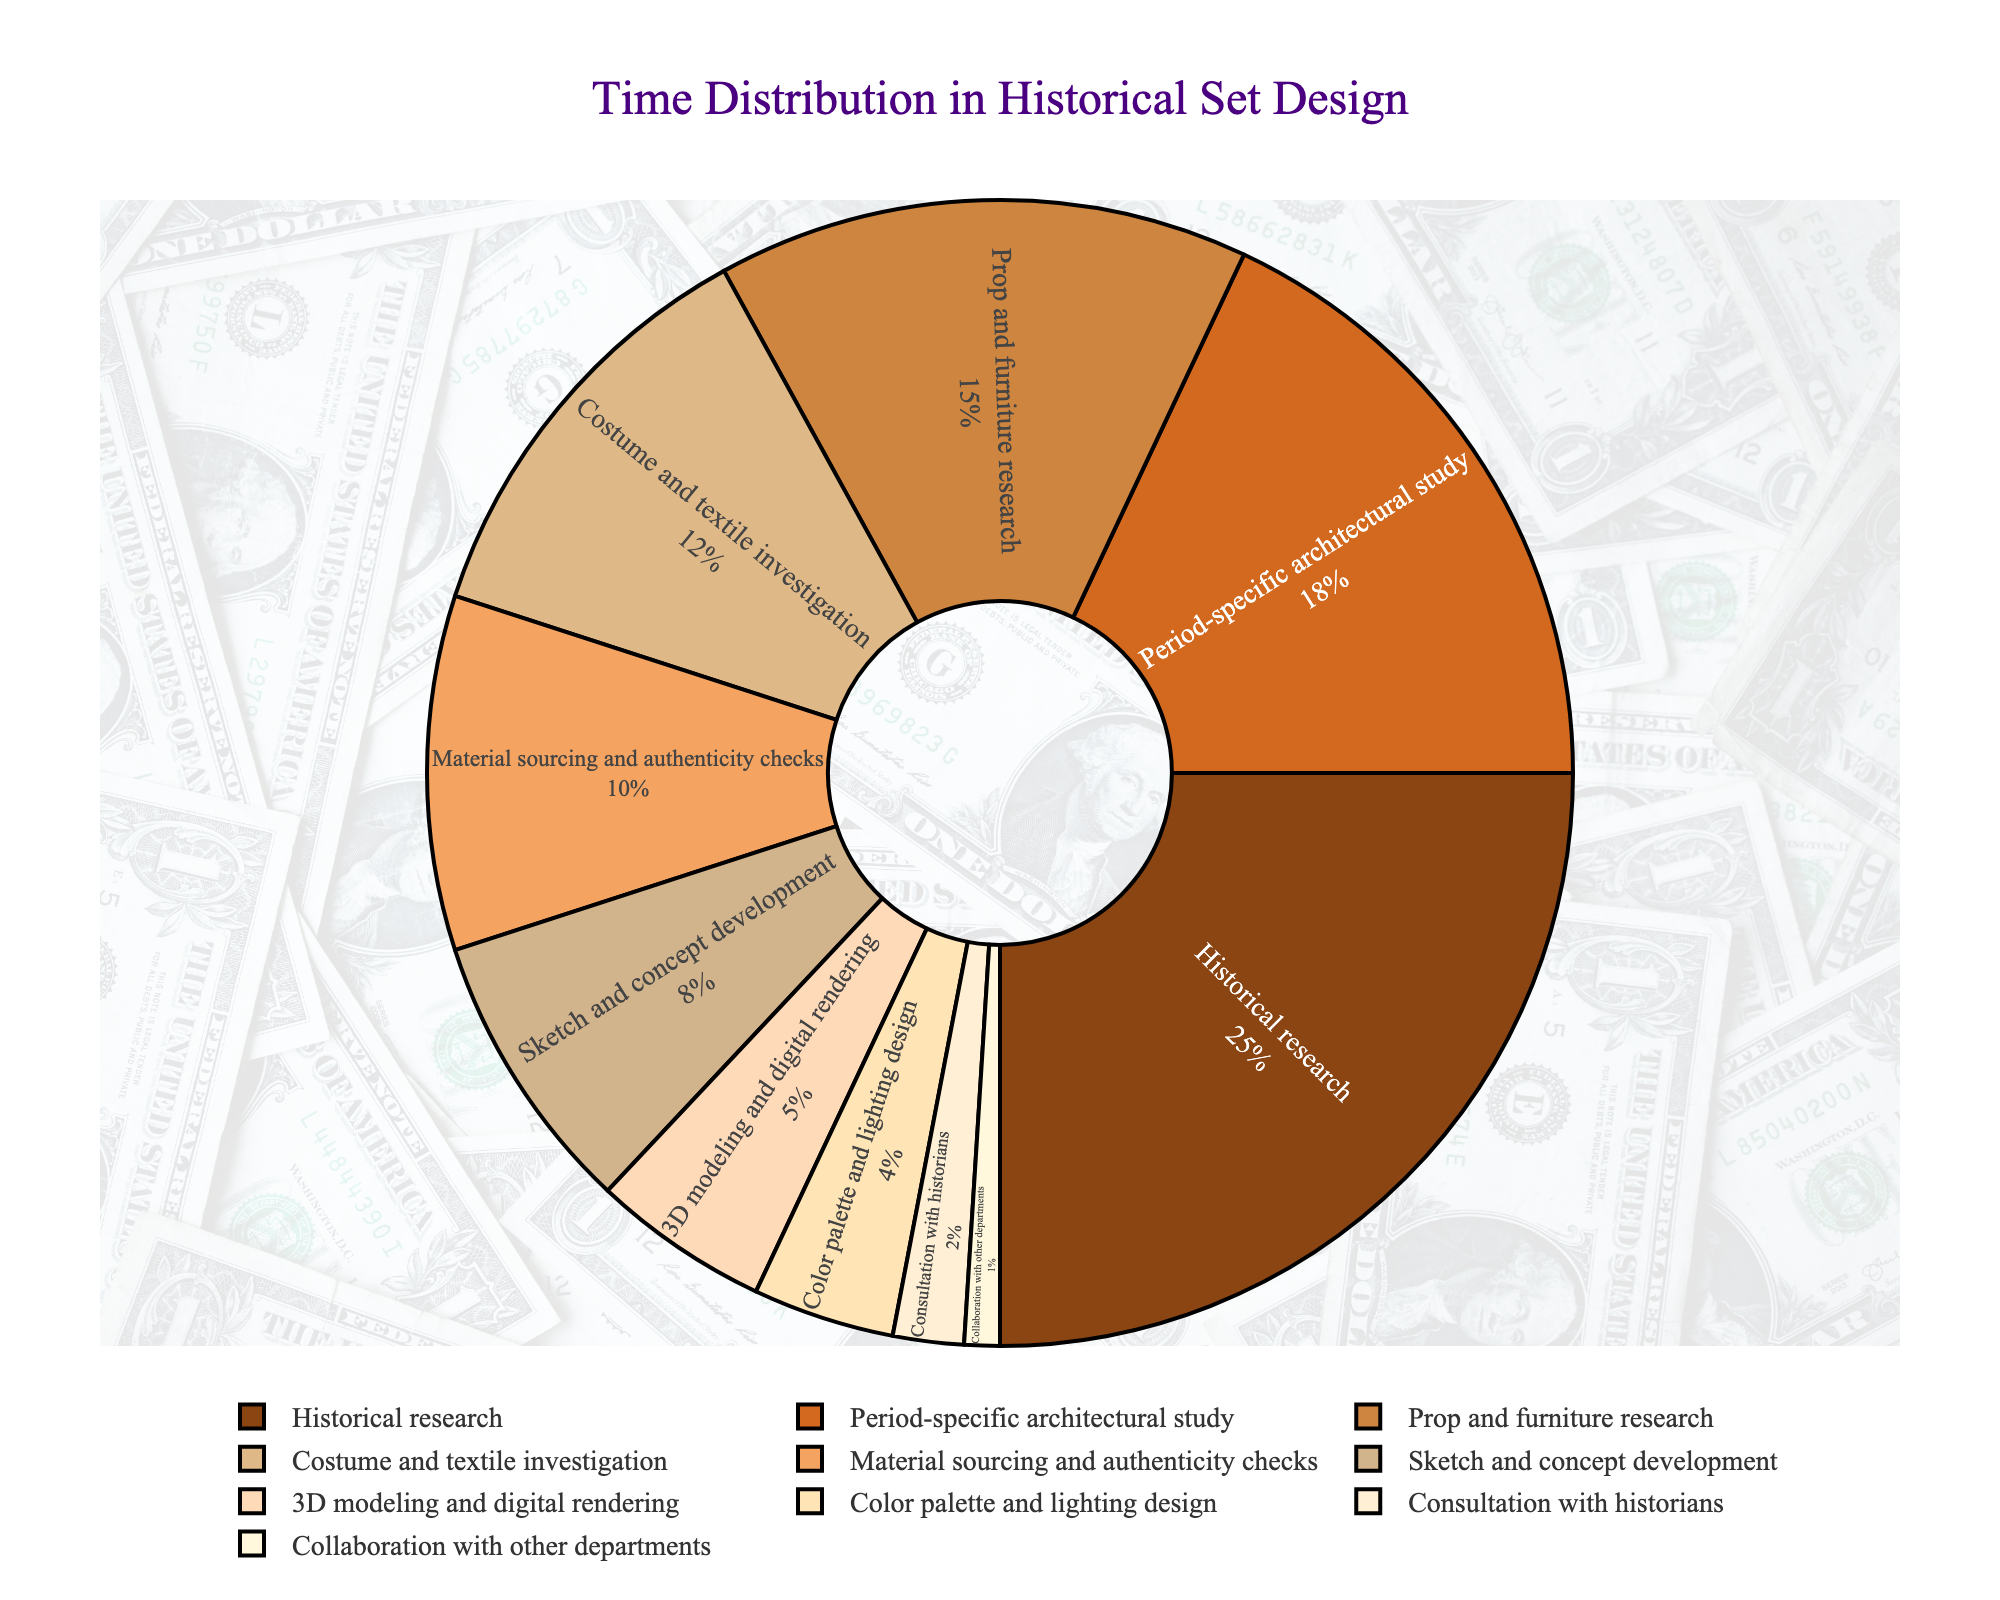What percentage of time is spent on historical research? Locate "Historical research" in the pie chart, and directly read the associated percentage.
Answer: 25% Which stage takes up more time, costume and textile investigation or material sourcing and authenticity checks? Compare the percentages for "Costume and textile investigation" and "Material sourcing and authenticity checks." Costume and textile investigation has 12%, while material sourcing and authenticity checks have 10%.
Answer: Costume and textile investigation How much time is collectively spent on 3D modeling and digital rendering and consultation with historians? Add the percentages of "3D modeling and digital rendering" (5%) and "Consultation with historians" (2%). 5% + 2% = 7%.
Answer: 7% What is the smallest time-consuming stage in the chart? Identify the stage with the smallest percentage from the pie chart. "Collaboration with other departments" has 1%, which is the smallest.
Answer: Collaboration with other departments How does the percentage of historical research compare to the sum of sketch and concept development and period-specific architectural study? Calculate the sum of "Sketch and concept development" (8%) and "Period-specific architectural study" (18%). 8% + 18% = 26%. Historical research is 25%, which is slightly less.
Answer: Less What is the combined percentage of time spent on prop and furniture research and consultation with historians? Add the percentages of "Prop and furniture research" (15%) and "Consultation with historians" (2%). 15% + 2% = 17%.
Answer: 17% Which activity uses less time, color palette and lighting design or material sourcing and authenticity checks? Compare the percentages for "Color palette and lighting design" (4%) and "Material sourcing and authenticity checks" (10%).
Answer: Color palette and lighting design What is the total time spent on stages related to visual aspects (color palette and lighting design, and sketch and concept development)? Add the percentages of "Color palette and lighting design" (4%) and "Sketch and concept development" (8%). 4% + 8% = 12%.
Answer: 12% How does the time spent on period-specific architectural study compare to the historical research stage? Compare the percentages for "Period-specific architectural study" (18%) and "Historical research" (25%).
Answer: Less 